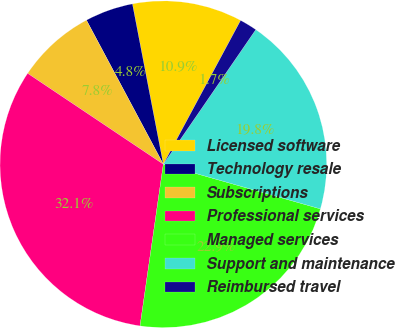<chart> <loc_0><loc_0><loc_500><loc_500><pie_chart><fcel>Licensed software<fcel>Technology resale<fcel>Subscriptions<fcel>Professional services<fcel>Managed services<fcel>Support and maintenance<fcel>Reimbursed travel<nl><fcel>10.88%<fcel>4.77%<fcel>7.81%<fcel>32.12%<fcel>22.87%<fcel>19.83%<fcel>1.73%<nl></chart> 